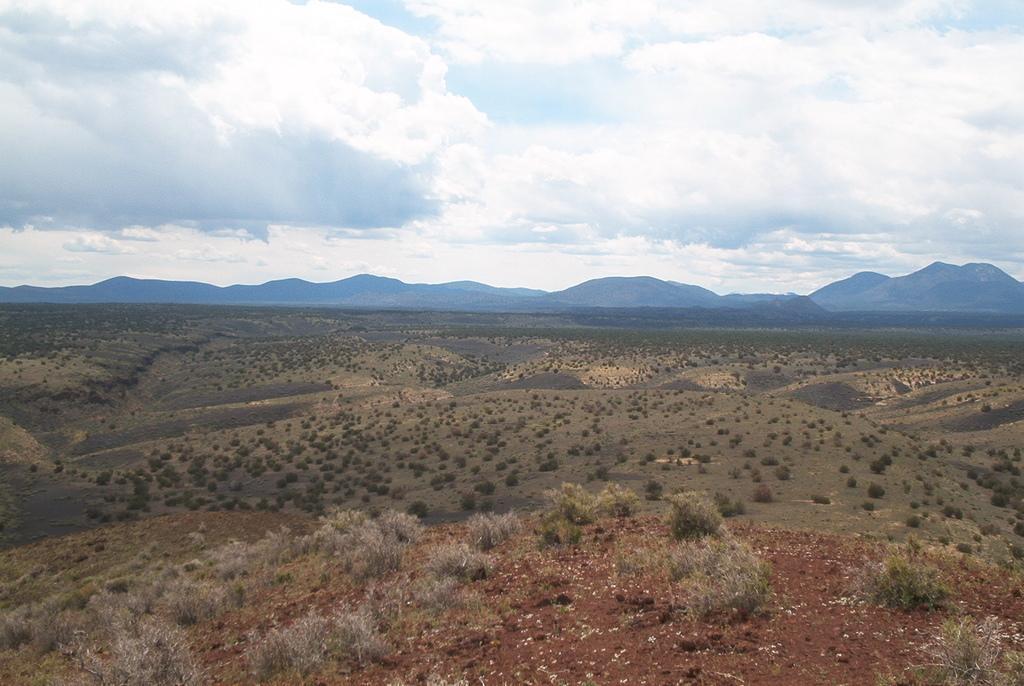Describe this image in one or two sentences. In the center of the image we can see mountains, trees, grass. At the bottom of the image we can see some plants, ground. At the top of the image clouds are present in the sky. 